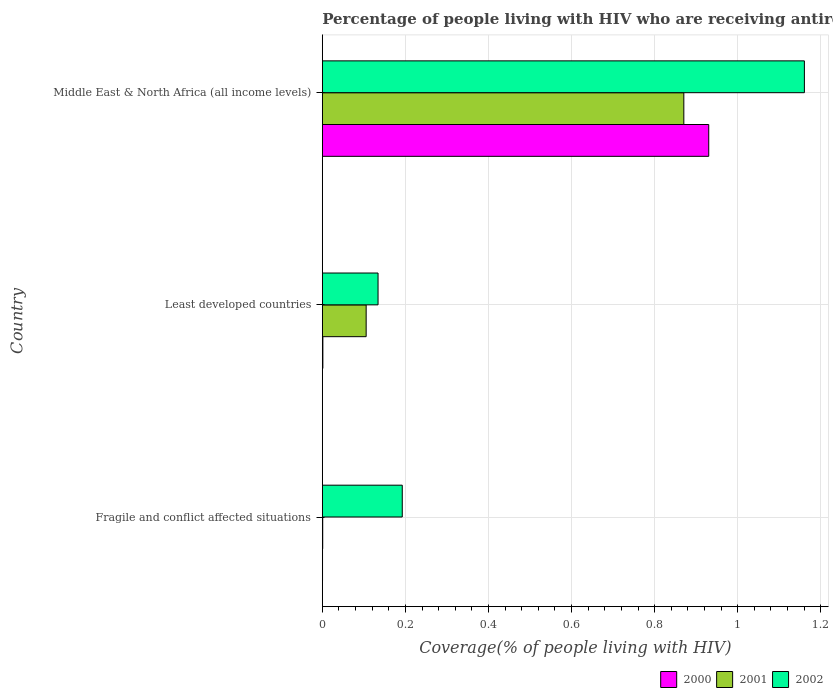How many different coloured bars are there?
Provide a succinct answer. 3. How many groups of bars are there?
Your answer should be very brief. 3. How many bars are there on the 3rd tick from the top?
Provide a short and direct response. 3. How many bars are there on the 3rd tick from the bottom?
Your answer should be very brief. 3. What is the label of the 3rd group of bars from the top?
Make the answer very short. Fragile and conflict affected situations. What is the percentage of the HIV infected people who are receiving antiretroviral therapy in 2002 in Fragile and conflict affected situations?
Give a very brief answer. 0.19. Across all countries, what is the maximum percentage of the HIV infected people who are receiving antiretroviral therapy in 2001?
Offer a terse response. 0.87. Across all countries, what is the minimum percentage of the HIV infected people who are receiving antiretroviral therapy in 2001?
Your response must be concise. 0. In which country was the percentage of the HIV infected people who are receiving antiretroviral therapy in 2001 maximum?
Ensure brevity in your answer.  Middle East & North Africa (all income levels). In which country was the percentage of the HIV infected people who are receiving antiretroviral therapy in 2000 minimum?
Offer a very short reply. Fragile and conflict affected situations. What is the total percentage of the HIV infected people who are receiving antiretroviral therapy in 2002 in the graph?
Provide a succinct answer. 1.49. What is the difference between the percentage of the HIV infected people who are receiving antiretroviral therapy in 2000 in Fragile and conflict affected situations and that in Least developed countries?
Provide a short and direct response. -0. What is the difference between the percentage of the HIV infected people who are receiving antiretroviral therapy in 2002 in Fragile and conflict affected situations and the percentage of the HIV infected people who are receiving antiretroviral therapy in 2000 in Middle East & North Africa (all income levels)?
Keep it short and to the point. -0.74. What is the average percentage of the HIV infected people who are receiving antiretroviral therapy in 2000 per country?
Make the answer very short. 0.31. What is the difference between the percentage of the HIV infected people who are receiving antiretroviral therapy in 2002 and percentage of the HIV infected people who are receiving antiretroviral therapy in 2001 in Middle East & North Africa (all income levels)?
Your answer should be very brief. 0.29. What is the ratio of the percentage of the HIV infected people who are receiving antiretroviral therapy in 2002 in Least developed countries to that in Middle East & North Africa (all income levels)?
Offer a very short reply. 0.12. Is the percentage of the HIV infected people who are receiving antiretroviral therapy in 2000 in Fragile and conflict affected situations less than that in Middle East & North Africa (all income levels)?
Provide a succinct answer. Yes. What is the difference between the highest and the second highest percentage of the HIV infected people who are receiving antiretroviral therapy in 2000?
Ensure brevity in your answer.  0.93. What is the difference between the highest and the lowest percentage of the HIV infected people who are receiving antiretroviral therapy in 2002?
Offer a very short reply. 1.03. In how many countries, is the percentage of the HIV infected people who are receiving antiretroviral therapy in 2000 greater than the average percentage of the HIV infected people who are receiving antiretroviral therapy in 2000 taken over all countries?
Offer a terse response. 1. Is the sum of the percentage of the HIV infected people who are receiving antiretroviral therapy in 2002 in Fragile and conflict affected situations and Least developed countries greater than the maximum percentage of the HIV infected people who are receiving antiretroviral therapy in 2001 across all countries?
Provide a short and direct response. No. What does the 1st bar from the bottom in Middle East & North Africa (all income levels) represents?
Give a very brief answer. 2000. Is it the case that in every country, the sum of the percentage of the HIV infected people who are receiving antiretroviral therapy in 2000 and percentage of the HIV infected people who are receiving antiretroviral therapy in 2001 is greater than the percentage of the HIV infected people who are receiving antiretroviral therapy in 2002?
Offer a very short reply. No. How many bars are there?
Provide a short and direct response. 9. How many countries are there in the graph?
Your response must be concise. 3. What is the difference between two consecutive major ticks on the X-axis?
Your answer should be compact. 0.2. Does the graph contain grids?
Keep it short and to the point. Yes. How are the legend labels stacked?
Your response must be concise. Horizontal. What is the title of the graph?
Provide a succinct answer. Percentage of people living with HIV who are receiving antiretroviral therapy. Does "1961" appear as one of the legend labels in the graph?
Your answer should be compact. No. What is the label or title of the X-axis?
Offer a very short reply. Coverage(% of people living with HIV). What is the Coverage(% of people living with HIV) in 2000 in Fragile and conflict affected situations?
Give a very brief answer. 0. What is the Coverage(% of people living with HIV) of 2001 in Fragile and conflict affected situations?
Make the answer very short. 0. What is the Coverage(% of people living with HIV) in 2002 in Fragile and conflict affected situations?
Give a very brief answer. 0.19. What is the Coverage(% of people living with HIV) of 2000 in Least developed countries?
Keep it short and to the point. 0. What is the Coverage(% of people living with HIV) in 2001 in Least developed countries?
Provide a short and direct response. 0.11. What is the Coverage(% of people living with HIV) of 2002 in Least developed countries?
Provide a succinct answer. 0.13. What is the Coverage(% of people living with HIV) in 2000 in Middle East & North Africa (all income levels)?
Your response must be concise. 0.93. What is the Coverage(% of people living with HIV) in 2001 in Middle East & North Africa (all income levels)?
Make the answer very short. 0.87. What is the Coverage(% of people living with HIV) of 2002 in Middle East & North Africa (all income levels)?
Provide a succinct answer. 1.16. Across all countries, what is the maximum Coverage(% of people living with HIV) of 2000?
Make the answer very short. 0.93. Across all countries, what is the maximum Coverage(% of people living with HIV) of 2001?
Offer a very short reply. 0.87. Across all countries, what is the maximum Coverage(% of people living with HIV) of 2002?
Your answer should be very brief. 1.16. Across all countries, what is the minimum Coverage(% of people living with HIV) of 2000?
Ensure brevity in your answer.  0. Across all countries, what is the minimum Coverage(% of people living with HIV) of 2001?
Provide a short and direct response. 0. Across all countries, what is the minimum Coverage(% of people living with HIV) in 2002?
Give a very brief answer. 0.13. What is the total Coverage(% of people living with HIV) in 2000 in the graph?
Ensure brevity in your answer.  0.93. What is the total Coverage(% of people living with HIV) of 2001 in the graph?
Give a very brief answer. 0.98. What is the total Coverage(% of people living with HIV) in 2002 in the graph?
Keep it short and to the point. 1.49. What is the difference between the Coverage(% of people living with HIV) in 2000 in Fragile and conflict affected situations and that in Least developed countries?
Your answer should be compact. -0. What is the difference between the Coverage(% of people living with HIV) of 2001 in Fragile and conflict affected situations and that in Least developed countries?
Your response must be concise. -0.1. What is the difference between the Coverage(% of people living with HIV) of 2002 in Fragile and conflict affected situations and that in Least developed countries?
Your response must be concise. 0.06. What is the difference between the Coverage(% of people living with HIV) in 2000 in Fragile and conflict affected situations and that in Middle East & North Africa (all income levels)?
Your answer should be compact. -0.93. What is the difference between the Coverage(% of people living with HIV) in 2001 in Fragile and conflict affected situations and that in Middle East & North Africa (all income levels)?
Give a very brief answer. -0.87. What is the difference between the Coverage(% of people living with HIV) of 2002 in Fragile and conflict affected situations and that in Middle East & North Africa (all income levels)?
Keep it short and to the point. -0.97. What is the difference between the Coverage(% of people living with HIV) of 2000 in Least developed countries and that in Middle East & North Africa (all income levels)?
Offer a very short reply. -0.93. What is the difference between the Coverage(% of people living with HIV) of 2001 in Least developed countries and that in Middle East & North Africa (all income levels)?
Keep it short and to the point. -0.76. What is the difference between the Coverage(% of people living with HIV) of 2002 in Least developed countries and that in Middle East & North Africa (all income levels)?
Your answer should be very brief. -1.03. What is the difference between the Coverage(% of people living with HIV) of 2000 in Fragile and conflict affected situations and the Coverage(% of people living with HIV) of 2001 in Least developed countries?
Your answer should be very brief. -0.1. What is the difference between the Coverage(% of people living with HIV) in 2000 in Fragile and conflict affected situations and the Coverage(% of people living with HIV) in 2002 in Least developed countries?
Provide a short and direct response. -0.13. What is the difference between the Coverage(% of people living with HIV) in 2001 in Fragile and conflict affected situations and the Coverage(% of people living with HIV) in 2002 in Least developed countries?
Your answer should be compact. -0.13. What is the difference between the Coverage(% of people living with HIV) in 2000 in Fragile and conflict affected situations and the Coverage(% of people living with HIV) in 2001 in Middle East & North Africa (all income levels)?
Ensure brevity in your answer.  -0.87. What is the difference between the Coverage(% of people living with HIV) of 2000 in Fragile and conflict affected situations and the Coverage(% of people living with HIV) of 2002 in Middle East & North Africa (all income levels)?
Make the answer very short. -1.16. What is the difference between the Coverage(% of people living with HIV) in 2001 in Fragile and conflict affected situations and the Coverage(% of people living with HIV) in 2002 in Middle East & North Africa (all income levels)?
Make the answer very short. -1.16. What is the difference between the Coverage(% of people living with HIV) of 2000 in Least developed countries and the Coverage(% of people living with HIV) of 2001 in Middle East & North Africa (all income levels)?
Keep it short and to the point. -0.87. What is the difference between the Coverage(% of people living with HIV) of 2000 in Least developed countries and the Coverage(% of people living with HIV) of 2002 in Middle East & North Africa (all income levels)?
Make the answer very short. -1.16. What is the difference between the Coverage(% of people living with HIV) of 2001 in Least developed countries and the Coverage(% of people living with HIV) of 2002 in Middle East & North Africa (all income levels)?
Your response must be concise. -1.05. What is the average Coverage(% of people living with HIV) in 2000 per country?
Your answer should be compact. 0.31. What is the average Coverage(% of people living with HIV) of 2001 per country?
Provide a succinct answer. 0.33. What is the average Coverage(% of people living with HIV) of 2002 per country?
Give a very brief answer. 0.5. What is the difference between the Coverage(% of people living with HIV) of 2000 and Coverage(% of people living with HIV) of 2001 in Fragile and conflict affected situations?
Offer a terse response. -0. What is the difference between the Coverage(% of people living with HIV) of 2000 and Coverage(% of people living with HIV) of 2002 in Fragile and conflict affected situations?
Offer a very short reply. -0.19. What is the difference between the Coverage(% of people living with HIV) in 2001 and Coverage(% of people living with HIV) in 2002 in Fragile and conflict affected situations?
Offer a very short reply. -0.19. What is the difference between the Coverage(% of people living with HIV) in 2000 and Coverage(% of people living with HIV) in 2001 in Least developed countries?
Your answer should be compact. -0.1. What is the difference between the Coverage(% of people living with HIV) in 2000 and Coverage(% of people living with HIV) in 2002 in Least developed countries?
Your answer should be very brief. -0.13. What is the difference between the Coverage(% of people living with HIV) in 2001 and Coverage(% of people living with HIV) in 2002 in Least developed countries?
Keep it short and to the point. -0.03. What is the difference between the Coverage(% of people living with HIV) of 2000 and Coverage(% of people living with HIV) of 2001 in Middle East & North Africa (all income levels)?
Offer a very short reply. 0.06. What is the difference between the Coverage(% of people living with HIV) in 2000 and Coverage(% of people living with HIV) in 2002 in Middle East & North Africa (all income levels)?
Your response must be concise. -0.23. What is the difference between the Coverage(% of people living with HIV) in 2001 and Coverage(% of people living with HIV) in 2002 in Middle East & North Africa (all income levels)?
Offer a terse response. -0.29. What is the ratio of the Coverage(% of people living with HIV) of 2000 in Fragile and conflict affected situations to that in Least developed countries?
Your response must be concise. 0.36. What is the ratio of the Coverage(% of people living with HIV) in 2001 in Fragile and conflict affected situations to that in Least developed countries?
Offer a very short reply. 0.01. What is the ratio of the Coverage(% of people living with HIV) in 2002 in Fragile and conflict affected situations to that in Least developed countries?
Provide a short and direct response. 1.43. What is the ratio of the Coverage(% of people living with HIV) in 2001 in Fragile and conflict affected situations to that in Middle East & North Africa (all income levels)?
Ensure brevity in your answer.  0. What is the ratio of the Coverage(% of people living with HIV) in 2002 in Fragile and conflict affected situations to that in Middle East & North Africa (all income levels)?
Keep it short and to the point. 0.17. What is the ratio of the Coverage(% of people living with HIV) of 2000 in Least developed countries to that in Middle East & North Africa (all income levels)?
Provide a succinct answer. 0. What is the ratio of the Coverage(% of people living with HIV) in 2001 in Least developed countries to that in Middle East & North Africa (all income levels)?
Keep it short and to the point. 0.12. What is the ratio of the Coverage(% of people living with HIV) in 2002 in Least developed countries to that in Middle East & North Africa (all income levels)?
Give a very brief answer. 0.12. What is the difference between the highest and the second highest Coverage(% of people living with HIV) in 2000?
Keep it short and to the point. 0.93. What is the difference between the highest and the second highest Coverage(% of people living with HIV) in 2001?
Keep it short and to the point. 0.76. What is the difference between the highest and the second highest Coverage(% of people living with HIV) in 2002?
Give a very brief answer. 0.97. What is the difference between the highest and the lowest Coverage(% of people living with HIV) of 2000?
Offer a very short reply. 0.93. What is the difference between the highest and the lowest Coverage(% of people living with HIV) in 2001?
Make the answer very short. 0.87. What is the difference between the highest and the lowest Coverage(% of people living with HIV) of 2002?
Your response must be concise. 1.03. 